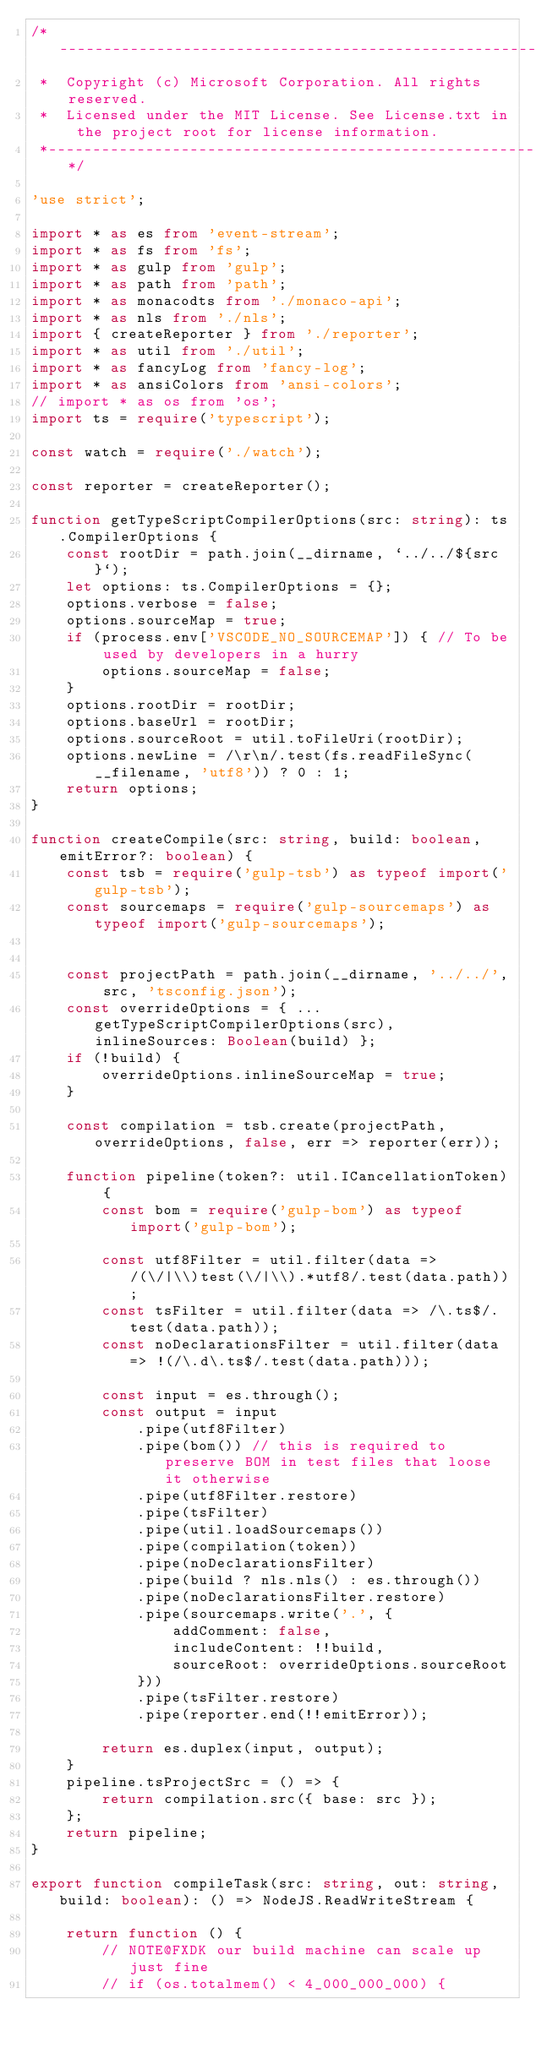<code> <loc_0><loc_0><loc_500><loc_500><_TypeScript_>/*---------------------------------------------------------------------------------------------
 *  Copyright (c) Microsoft Corporation. All rights reserved.
 *  Licensed under the MIT License. See License.txt in the project root for license information.
 *--------------------------------------------------------------------------------------------*/

'use strict';

import * as es from 'event-stream';
import * as fs from 'fs';
import * as gulp from 'gulp';
import * as path from 'path';
import * as monacodts from './monaco-api';
import * as nls from './nls';
import { createReporter } from './reporter';
import * as util from './util';
import * as fancyLog from 'fancy-log';
import * as ansiColors from 'ansi-colors';
// import * as os from 'os';
import ts = require('typescript');

const watch = require('./watch');

const reporter = createReporter();

function getTypeScriptCompilerOptions(src: string): ts.CompilerOptions {
	const rootDir = path.join(__dirname, `../../${src}`);
	let options: ts.CompilerOptions = {};
	options.verbose = false;
	options.sourceMap = true;
	if (process.env['VSCODE_NO_SOURCEMAP']) { // To be used by developers in a hurry
		options.sourceMap = false;
	}
	options.rootDir = rootDir;
	options.baseUrl = rootDir;
	options.sourceRoot = util.toFileUri(rootDir);
	options.newLine = /\r\n/.test(fs.readFileSync(__filename, 'utf8')) ? 0 : 1;
	return options;
}

function createCompile(src: string, build: boolean, emitError?: boolean) {
	const tsb = require('gulp-tsb') as typeof import('gulp-tsb');
	const sourcemaps = require('gulp-sourcemaps') as typeof import('gulp-sourcemaps');


	const projectPath = path.join(__dirname, '../../', src, 'tsconfig.json');
	const overrideOptions = { ...getTypeScriptCompilerOptions(src), inlineSources: Boolean(build) };
	if (!build) {
		overrideOptions.inlineSourceMap = true;
	}

	const compilation = tsb.create(projectPath, overrideOptions, false, err => reporter(err));

	function pipeline(token?: util.ICancellationToken) {
		const bom = require('gulp-bom') as typeof import('gulp-bom');

		const utf8Filter = util.filter(data => /(\/|\\)test(\/|\\).*utf8/.test(data.path));
		const tsFilter = util.filter(data => /\.ts$/.test(data.path));
		const noDeclarationsFilter = util.filter(data => !(/\.d\.ts$/.test(data.path)));

		const input = es.through();
		const output = input
			.pipe(utf8Filter)
			.pipe(bom()) // this is required to preserve BOM in test files that loose it otherwise
			.pipe(utf8Filter.restore)
			.pipe(tsFilter)
			.pipe(util.loadSourcemaps())
			.pipe(compilation(token))
			.pipe(noDeclarationsFilter)
			.pipe(build ? nls.nls() : es.through())
			.pipe(noDeclarationsFilter.restore)
			.pipe(sourcemaps.write('.', {
				addComment: false,
				includeContent: !!build,
				sourceRoot: overrideOptions.sourceRoot
			}))
			.pipe(tsFilter.restore)
			.pipe(reporter.end(!!emitError));

		return es.duplex(input, output);
	}
	pipeline.tsProjectSrc = () => {
		return compilation.src({ base: src });
	};
	return pipeline;
}

export function compileTask(src: string, out: string, build: boolean): () => NodeJS.ReadWriteStream {

	return function () {
		// NOTE@FXDK our build machine can scale up just fine
		// if (os.totalmem() < 4_000_000_000) {</code> 